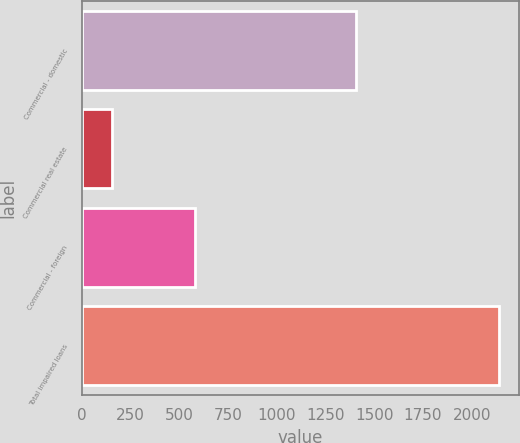Convert chart. <chart><loc_0><loc_0><loc_500><loc_500><bar_chart><fcel>Commercial - domestic<fcel>Commercial real estate<fcel>Commercial - foreign<fcel>Total impaired loans<nl><fcel>1404<fcel>153<fcel>581<fcel>2138<nl></chart> 